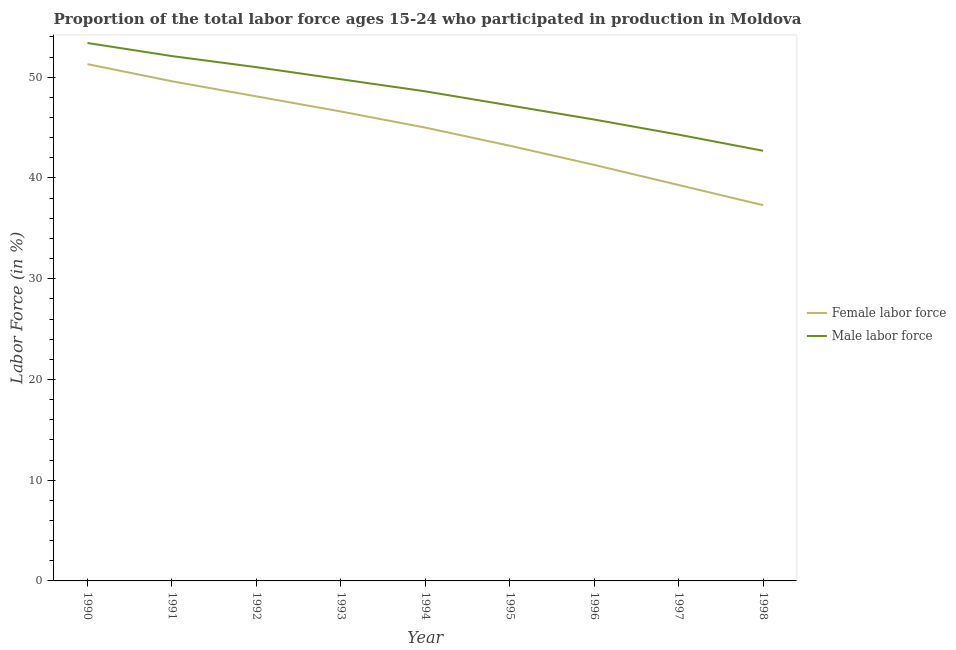What is the percentage of male labour force in 1998?
Make the answer very short. 42.7. Across all years, what is the maximum percentage of male labour force?
Ensure brevity in your answer.  53.4. Across all years, what is the minimum percentage of male labour force?
Ensure brevity in your answer.  42.7. In which year was the percentage of female labor force maximum?
Keep it short and to the point. 1990. What is the total percentage of female labor force in the graph?
Provide a succinct answer. 401.7. What is the difference between the percentage of female labor force in 1992 and that in 1995?
Your answer should be very brief. 4.9. What is the difference between the percentage of male labour force in 1991 and the percentage of female labor force in 1998?
Ensure brevity in your answer.  14.8. What is the average percentage of male labour force per year?
Give a very brief answer. 48.32. In the year 1995, what is the difference between the percentage of female labor force and percentage of male labour force?
Keep it short and to the point. -4. What is the ratio of the percentage of female labor force in 1991 to that in 1995?
Make the answer very short. 1.15. Is the difference between the percentage of male labour force in 1996 and 1997 greater than the difference between the percentage of female labor force in 1996 and 1997?
Provide a succinct answer. No. What is the difference between the highest and the second highest percentage of female labor force?
Give a very brief answer. 1.7. Is the sum of the percentage of female labor force in 1990 and 1996 greater than the maximum percentage of male labour force across all years?
Your answer should be compact. Yes. Is the percentage of female labor force strictly less than the percentage of male labour force over the years?
Provide a short and direct response. Yes. How many years are there in the graph?
Offer a very short reply. 9. Does the graph contain grids?
Give a very brief answer. No. Where does the legend appear in the graph?
Offer a terse response. Center right. How many legend labels are there?
Keep it short and to the point. 2. How are the legend labels stacked?
Your answer should be very brief. Vertical. What is the title of the graph?
Keep it short and to the point. Proportion of the total labor force ages 15-24 who participated in production in Moldova. What is the label or title of the X-axis?
Make the answer very short. Year. What is the label or title of the Y-axis?
Offer a very short reply. Labor Force (in %). What is the Labor Force (in %) in Female labor force in 1990?
Keep it short and to the point. 51.3. What is the Labor Force (in %) in Male labor force in 1990?
Provide a succinct answer. 53.4. What is the Labor Force (in %) of Female labor force in 1991?
Provide a succinct answer. 49.6. What is the Labor Force (in %) of Male labor force in 1991?
Your response must be concise. 52.1. What is the Labor Force (in %) of Female labor force in 1992?
Offer a very short reply. 48.1. What is the Labor Force (in %) of Female labor force in 1993?
Provide a succinct answer. 46.6. What is the Labor Force (in %) in Male labor force in 1993?
Your answer should be very brief. 49.8. What is the Labor Force (in %) in Female labor force in 1994?
Your answer should be very brief. 45. What is the Labor Force (in %) of Male labor force in 1994?
Offer a terse response. 48.6. What is the Labor Force (in %) of Female labor force in 1995?
Your answer should be compact. 43.2. What is the Labor Force (in %) in Male labor force in 1995?
Your answer should be very brief. 47.2. What is the Labor Force (in %) of Female labor force in 1996?
Give a very brief answer. 41.3. What is the Labor Force (in %) of Male labor force in 1996?
Keep it short and to the point. 45.8. What is the Labor Force (in %) in Female labor force in 1997?
Provide a succinct answer. 39.3. What is the Labor Force (in %) of Male labor force in 1997?
Make the answer very short. 44.3. What is the Labor Force (in %) in Female labor force in 1998?
Offer a very short reply. 37.3. What is the Labor Force (in %) of Male labor force in 1998?
Ensure brevity in your answer.  42.7. Across all years, what is the maximum Labor Force (in %) of Female labor force?
Your response must be concise. 51.3. Across all years, what is the maximum Labor Force (in %) of Male labor force?
Your response must be concise. 53.4. Across all years, what is the minimum Labor Force (in %) in Female labor force?
Keep it short and to the point. 37.3. Across all years, what is the minimum Labor Force (in %) in Male labor force?
Give a very brief answer. 42.7. What is the total Labor Force (in %) of Female labor force in the graph?
Give a very brief answer. 401.7. What is the total Labor Force (in %) in Male labor force in the graph?
Provide a succinct answer. 434.9. What is the difference between the Labor Force (in %) of Female labor force in 1990 and that in 1991?
Make the answer very short. 1.7. What is the difference between the Labor Force (in %) in Male labor force in 1990 and that in 1991?
Your answer should be compact. 1.3. What is the difference between the Labor Force (in %) in Male labor force in 1990 and that in 1992?
Your answer should be very brief. 2.4. What is the difference between the Labor Force (in %) in Female labor force in 1990 and that in 1993?
Your answer should be very brief. 4.7. What is the difference between the Labor Force (in %) in Male labor force in 1990 and that in 1993?
Keep it short and to the point. 3.6. What is the difference between the Labor Force (in %) of Female labor force in 1990 and that in 1995?
Keep it short and to the point. 8.1. What is the difference between the Labor Force (in %) in Male labor force in 1990 and that in 1996?
Make the answer very short. 7.6. What is the difference between the Labor Force (in %) of Female labor force in 1990 and that in 1997?
Make the answer very short. 12. What is the difference between the Labor Force (in %) of Male labor force in 1990 and that in 1997?
Your response must be concise. 9.1. What is the difference between the Labor Force (in %) in Female labor force in 1991 and that in 1992?
Your answer should be very brief. 1.5. What is the difference between the Labor Force (in %) in Female labor force in 1991 and that in 1993?
Your answer should be compact. 3. What is the difference between the Labor Force (in %) of Female labor force in 1991 and that in 1996?
Offer a terse response. 8.3. What is the difference between the Labor Force (in %) of Female labor force in 1991 and that in 1997?
Provide a short and direct response. 10.3. What is the difference between the Labor Force (in %) of Female labor force in 1991 and that in 1998?
Your response must be concise. 12.3. What is the difference between the Labor Force (in %) in Male labor force in 1991 and that in 1998?
Your answer should be very brief. 9.4. What is the difference between the Labor Force (in %) of Male labor force in 1992 and that in 1993?
Provide a succinct answer. 1.2. What is the difference between the Labor Force (in %) in Male labor force in 1992 and that in 1994?
Give a very brief answer. 2.4. What is the difference between the Labor Force (in %) of Male labor force in 1992 and that in 1995?
Your answer should be compact. 3.8. What is the difference between the Labor Force (in %) in Female labor force in 1992 and that in 1996?
Ensure brevity in your answer.  6.8. What is the difference between the Labor Force (in %) in Female labor force in 1992 and that in 1997?
Your answer should be compact. 8.8. What is the difference between the Labor Force (in %) in Male labor force in 1992 and that in 1998?
Offer a very short reply. 8.3. What is the difference between the Labor Force (in %) in Female labor force in 1993 and that in 1995?
Make the answer very short. 3.4. What is the difference between the Labor Force (in %) of Female labor force in 1993 and that in 1996?
Make the answer very short. 5.3. What is the difference between the Labor Force (in %) of Male labor force in 1993 and that in 1996?
Provide a succinct answer. 4. What is the difference between the Labor Force (in %) of Male labor force in 1993 and that in 1997?
Your answer should be compact. 5.5. What is the difference between the Labor Force (in %) of Female labor force in 1993 and that in 1998?
Offer a terse response. 9.3. What is the difference between the Labor Force (in %) of Male labor force in 1993 and that in 1998?
Your response must be concise. 7.1. What is the difference between the Labor Force (in %) in Male labor force in 1994 and that in 1995?
Offer a very short reply. 1.4. What is the difference between the Labor Force (in %) in Female labor force in 1994 and that in 1997?
Ensure brevity in your answer.  5.7. What is the difference between the Labor Force (in %) in Male labor force in 1995 and that in 1996?
Offer a very short reply. 1.4. What is the difference between the Labor Force (in %) of Male labor force in 1995 and that in 1997?
Your answer should be very brief. 2.9. What is the difference between the Labor Force (in %) in Male labor force in 1995 and that in 1998?
Provide a short and direct response. 4.5. What is the difference between the Labor Force (in %) of Female labor force in 1996 and that in 1997?
Make the answer very short. 2. What is the difference between the Labor Force (in %) in Male labor force in 1996 and that in 1997?
Make the answer very short. 1.5. What is the difference between the Labor Force (in %) of Female labor force in 1996 and that in 1998?
Keep it short and to the point. 4. What is the difference between the Labor Force (in %) of Female labor force in 1990 and the Labor Force (in %) of Male labor force in 1993?
Provide a succinct answer. 1.5. What is the difference between the Labor Force (in %) of Female labor force in 1990 and the Labor Force (in %) of Male labor force in 1994?
Give a very brief answer. 2.7. What is the difference between the Labor Force (in %) in Female labor force in 1990 and the Labor Force (in %) in Male labor force in 1996?
Keep it short and to the point. 5.5. What is the difference between the Labor Force (in %) of Female labor force in 1990 and the Labor Force (in %) of Male labor force in 1997?
Give a very brief answer. 7. What is the difference between the Labor Force (in %) in Female labor force in 1990 and the Labor Force (in %) in Male labor force in 1998?
Your answer should be very brief. 8.6. What is the difference between the Labor Force (in %) in Female labor force in 1991 and the Labor Force (in %) in Male labor force in 1993?
Give a very brief answer. -0.2. What is the difference between the Labor Force (in %) in Female labor force in 1991 and the Labor Force (in %) in Male labor force in 1994?
Offer a very short reply. 1. What is the difference between the Labor Force (in %) in Female labor force in 1991 and the Labor Force (in %) in Male labor force in 1995?
Provide a short and direct response. 2.4. What is the difference between the Labor Force (in %) of Female labor force in 1991 and the Labor Force (in %) of Male labor force in 1997?
Provide a short and direct response. 5.3. What is the difference between the Labor Force (in %) of Female labor force in 1992 and the Labor Force (in %) of Male labor force in 1994?
Your answer should be compact. -0.5. What is the difference between the Labor Force (in %) in Female labor force in 1992 and the Labor Force (in %) in Male labor force in 1998?
Ensure brevity in your answer.  5.4. What is the difference between the Labor Force (in %) of Female labor force in 1993 and the Labor Force (in %) of Male labor force in 1995?
Offer a very short reply. -0.6. What is the difference between the Labor Force (in %) of Female labor force in 1993 and the Labor Force (in %) of Male labor force in 1996?
Your answer should be compact. 0.8. What is the difference between the Labor Force (in %) of Female labor force in 1993 and the Labor Force (in %) of Male labor force in 1997?
Your answer should be very brief. 2.3. What is the difference between the Labor Force (in %) in Female labor force in 1993 and the Labor Force (in %) in Male labor force in 1998?
Offer a very short reply. 3.9. What is the difference between the Labor Force (in %) in Female labor force in 1994 and the Labor Force (in %) in Male labor force in 1998?
Make the answer very short. 2.3. What is the difference between the Labor Force (in %) of Female labor force in 1995 and the Labor Force (in %) of Male labor force in 1996?
Your answer should be very brief. -2.6. What is the difference between the Labor Force (in %) in Female labor force in 1995 and the Labor Force (in %) in Male labor force in 1998?
Offer a very short reply. 0.5. What is the difference between the Labor Force (in %) of Female labor force in 1996 and the Labor Force (in %) of Male labor force in 1998?
Give a very brief answer. -1.4. What is the average Labor Force (in %) in Female labor force per year?
Your response must be concise. 44.63. What is the average Labor Force (in %) of Male labor force per year?
Provide a succinct answer. 48.32. In the year 1995, what is the difference between the Labor Force (in %) of Female labor force and Labor Force (in %) of Male labor force?
Provide a succinct answer. -4. In the year 1997, what is the difference between the Labor Force (in %) of Female labor force and Labor Force (in %) of Male labor force?
Offer a very short reply. -5. In the year 1998, what is the difference between the Labor Force (in %) in Female labor force and Labor Force (in %) in Male labor force?
Offer a terse response. -5.4. What is the ratio of the Labor Force (in %) of Female labor force in 1990 to that in 1991?
Your response must be concise. 1.03. What is the ratio of the Labor Force (in %) in Female labor force in 1990 to that in 1992?
Offer a very short reply. 1.07. What is the ratio of the Labor Force (in %) in Male labor force in 1990 to that in 1992?
Your response must be concise. 1.05. What is the ratio of the Labor Force (in %) of Female labor force in 1990 to that in 1993?
Offer a very short reply. 1.1. What is the ratio of the Labor Force (in %) in Male labor force in 1990 to that in 1993?
Make the answer very short. 1.07. What is the ratio of the Labor Force (in %) of Female labor force in 1990 to that in 1994?
Your answer should be compact. 1.14. What is the ratio of the Labor Force (in %) of Male labor force in 1990 to that in 1994?
Give a very brief answer. 1.1. What is the ratio of the Labor Force (in %) of Female labor force in 1990 to that in 1995?
Provide a succinct answer. 1.19. What is the ratio of the Labor Force (in %) of Male labor force in 1990 to that in 1995?
Offer a terse response. 1.13. What is the ratio of the Labor Force (in %) of Female labor force in 1990 to that in 1996?
Your answer should be very brief. 1.24. What is the ratio of the Labor Force (in %) of Male labor force in 1990 to that in 1996?
Provide a short and direct response. 1.17. What is the ratio of the Labor Force (in %) of Female labor force in 1990 to that in 1997?
Make the answer very short. 1.31. What is the ratio of the Labor Force (in %) of Male labor force in 1990 to that in 1997?
Offer a terse response. 1.21. What is the ratio of the Labor Force (in %) of Female labor force in 1990 to that in 1998?
Offer a terse response. 1.38. What is the ratio of the Labor Force (in %) in Male labor force in 1990 to that in 1998?
Give a very brief answer. 1.25. What is the ratio of the Labor Force (in %) in Female labor force in 1991 to that in 1992?
Your answer should be very brief. 1.03. What is the ratio of the Labor Force (in %) of Male labor force in 1991 to that in 1992?
Provide a short and direct response. 1.02. What is the ratio of the Labor Force (in %) of Female labor force in 1991 to that in 1993?
Offer a very short reply. 1.06. What is the ratio of the Labor Force (in %) of Male labor force in 1991 to that in 1993?
Your response must be concise. 1.05. What is the ratio of the Labor Force (in %) in Female labor force in 1991 to that in 1994?
Your answer should be very brief. 1.1. What is the ratio of the Labor Force (in %) of Male labor force in 1991 to that in 1994?
Keep it short and to the point. 1.07. What is the ratio of the Labor Force (in %) in Female labor force in 1991 to that in 1995?
Give a very brief answer. 1.15. What is the ratio of the Labor Force (in %) in Male labor force in 1991 to that in 1995?
Your response must be concise. 1.1. What is the ratio of the Labor Force (in %) in Female labor force in 1991 to that in 1996?
Give a very brief answer. 1.2. What is the ratio of the Labor Force (in %) of Male labor force in 1991 to that in 1996?
Give a very brief answer. 1.14. What is the ratio of the Labor Force (in %) in Female labor force in 1991 to that in 1997?
Your response must be concise. 1.26. What is the ratio of the Labor Force (in %) in Male labor force in 1991 to that in 1997?
Give a very brief answer. 1.18. What is the ratio of the Labor Force (in %) in Female labor force in 1991 to that in 1998?
Provide a short and direct response. 1.33. What is the ratio of the Labor Force (in %) of Male labor force in 1991 to that in 1998?
Keep it short and to the point. 1.22. What is the ratio of the Labor Force (in %) of Female labor force in 1992 to that in 1993?
Offer a very short reply. 1.03. What is the ratio of the Labor Force (in %) in Male labor force in 1992 to that in 1993?
Provide a succinct answer. 1.02. What is the ratio of the Labor Force (in %) of Female labor force in 1992 to that in 1994?
Provide a short and direct response. 1.07. What is the ratio of the Labor Force (in %) of Male labor force in 1992 to that in 1994?
Your response must be concise. 1.05. What is the ratio of the Labor Force (in %) in Female labor force in 1992 to that in 1995?
Make the answer very short. 1.11. What is the ratio of the Labor Force (in %) in Male labor force in 1992 to that in 1995?
Ensure brevity in your answer.  1.08. What is the ratio of the Labor Force (in %) in Female labor force in 1992 to that in 1996?
Provide a succinct answer. 1.16. What is the ratio of the Labor Force (in %) of Male labor force in 1992 to that in 1996?
Ensure brevity in your answer.  1.11. What is the ratio of the Labor Force (in %) in Female labor force in 1992 to that in 1997?
Keep it short and to the point. 1.22. What is the ratio of the Labor Force (in %) in Male labor force in 1992 to that in 1997?
Keep it short and to the point. 1.15. What is the ratio of the Labor Force (in %) of Female labor force in 1992 to that in 1998?
Offer a very short reply. 1.29. What is the ratio of the Labor Force (in %) of Male labor force in 1992 to that in 1998?
Your answer should be very brief. 1.19. What is the ratio of the Labor Force (in %) of Female labor force in 1993 to that in 1994?
Ensure brevity in your answer.  1.04. What is the ratio of the Labor Force (in %) of Male labor force in 1993 to that in 1994?
Provide a short and direct response. 1.02. What is the ratio of the Labor Force (in %) in Female labor force in 1993 to that in 1995?
Offer a terse response. 1.08. What is the ratio of the Labor Force (in %) of Male labor force in 1993 to that in 1995?
Offer a very short reply. 1.06. What is the ratio of the Labor Force (in %) of Female labor force in 1993 to that in 1996?
Give a very brief answer. 1.13. What is the ratio of the Labor Force (in %) of Male labor force in 1993 to that in 1996?
Your answer should be very brief. 1.09. What is the ratio of the Labor Force (in %) in Female labor force in 1993 to that in 1997?
Ensure brevity in your answer.  1.19. What is the ratio of the Labor Force (in %) of Male labor force in 1993 to that in 1997?
Your answer should be compact. 1.12. What is the ratio of the Labor Force (in %) of Female labor force in 1993 to that in 1998?
Offer a terse response. 1.25. What is the ratio of the Labor Force (in %) in Male labor force in 1993 to that in 1998?
Your answer should be compact. 1.17. What is the ratio of the Labor Force (in %) in Female labor force in 1994 to that in 1995?
Provide a short and direct response. 1.04. What is the ratio of the Labor Force (in %) in Male labor force in 1994 to that in 1995?
Your answer should be very brief. 1.03. What is the ratio of the Labor Force (in %) of Female labor force in 1994 to that in 1996?
Ensure brevity in your answer.  1.09. What is the ratio of the Labor Force (in %) in Male labor force in 1994 to that in 1996?
Offer a terse response. 1.06. What is the ratio of the Labor Force (in %) of Female labor force in 1994 to that in 1997?
Offer a very short reply. 1.15. What is the ratio of the Labor Force (in %) in Male labor force in 1994 to that in 1997?
Make the answer very short. 1.1. What is the ratio of the Labor Force (in %) of Female labor force in 1994 to that in 1998?
Offer a very short reply. 1.21. What is the ratio of the Labor Force (in %) in Male labor force in 1994 to that in 1998?
Your response must be concise. 1.14. What is the ratio of the Labor Force (in %) in Female labor force in 1995 to that in 1996?
Keep it short and to the point. 1.05. What is the ratio of the Labor Force (in %) in Male labor force in 1995 to that in 1996?
Provide a succinct answer. 1.03. What is the ratio of the Labor Force (in %) in Female labor force in 1995 to that in 1997?
Your answer should be very brief. 1.1. What is the ratio of the Labor Force (in %) of Male labor force in 1995 to that in 1997?
Offer a terse response. 1.07. What is the ratio of the Labor Force (in %) in Female labor force in 1995 to that in 1998?
Offer a very short reply. 1.16. What is the ratio of the Labor Force (in %) in Male labor force in 1995 to that in 1998?
Your response must be concise. 1.11. What is the ratio of the Labor Force (in %) in Female labor force in 1996 to that in 1997?
Offer a terse response. 1.05. What is the ratio of the Labor Force (in %) in Male labor force in 1996 to that in 1997?
Offer a terse response. 1.03. What is the ratio of the Labor Force (in %) in Female labor force in 1996 to that in 1998?
Your answer should be very brief. 1.11. What is the ratio of the Labor Force (in %) of Male labor force in 1996 to that in 1998?
Offer a terse response. 1.07. What is the ratio of the Labor Force (in %) in Female labor force in 1997 to that in 1998?
Offer a terse response. 1.05. What is the ratio of the Labor Force (in %) of Male labor force in 1997 to that in 1998?
Your answer should be compact. 1.04. What is the difference between the highest and the second highest Labor Force (in %) in Male labor force?
Your response must be concise. 1.3. What is the difference between the highest and the lowest Labor Force (in %) in Female labor force?
Provide a succinct answer. 14. What is the difference between the highest and the lowest Labor Force (in %) in Male labor force?
Keep it short and to the point. 10.7. 